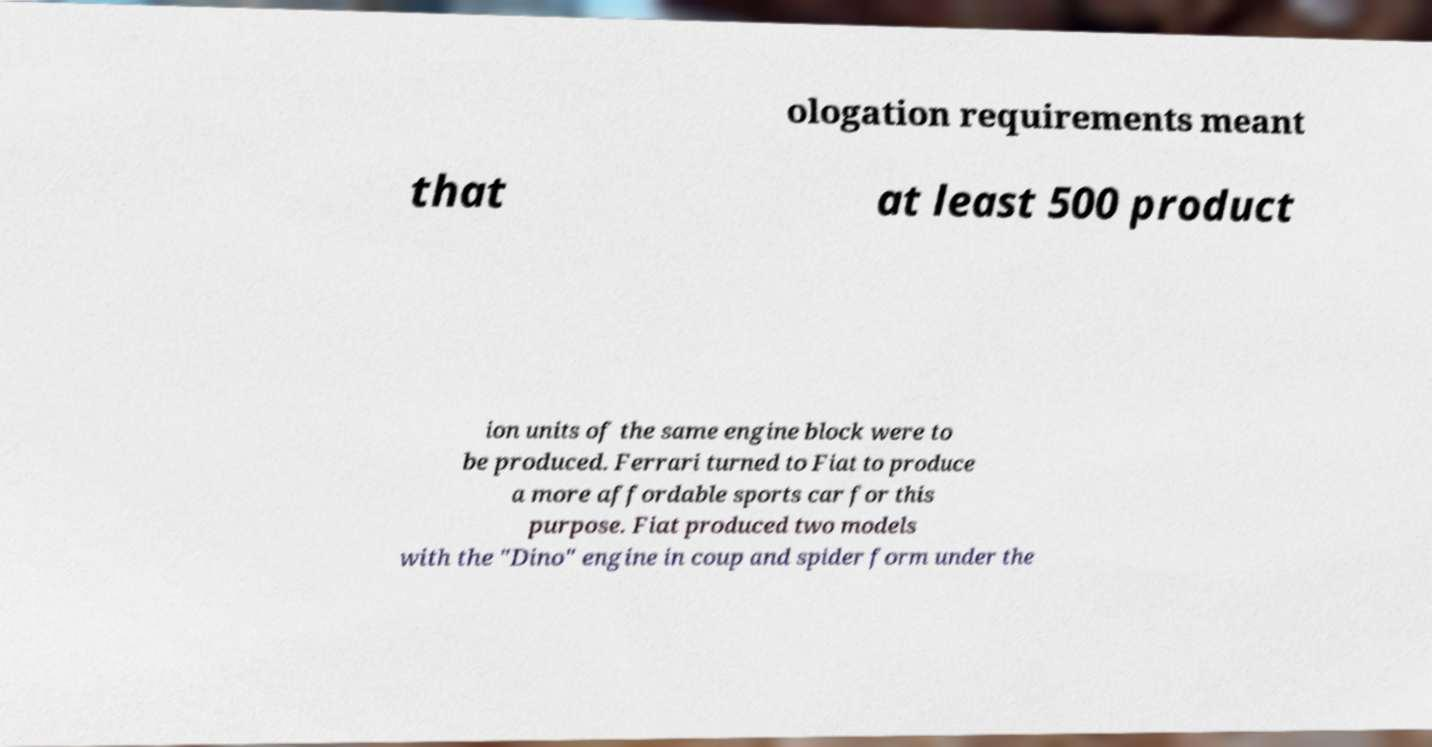For documentation purposes, I need the text within this image transcribed. Could you provide that? ologation requirements meant that at least 500 product ion units of the same engine block were to be produced. Ferrari turned to Fiat to produce a more affordable sports car for this purpose. Fiat produced two models with the "Dino" engine in coup and spider form under the 